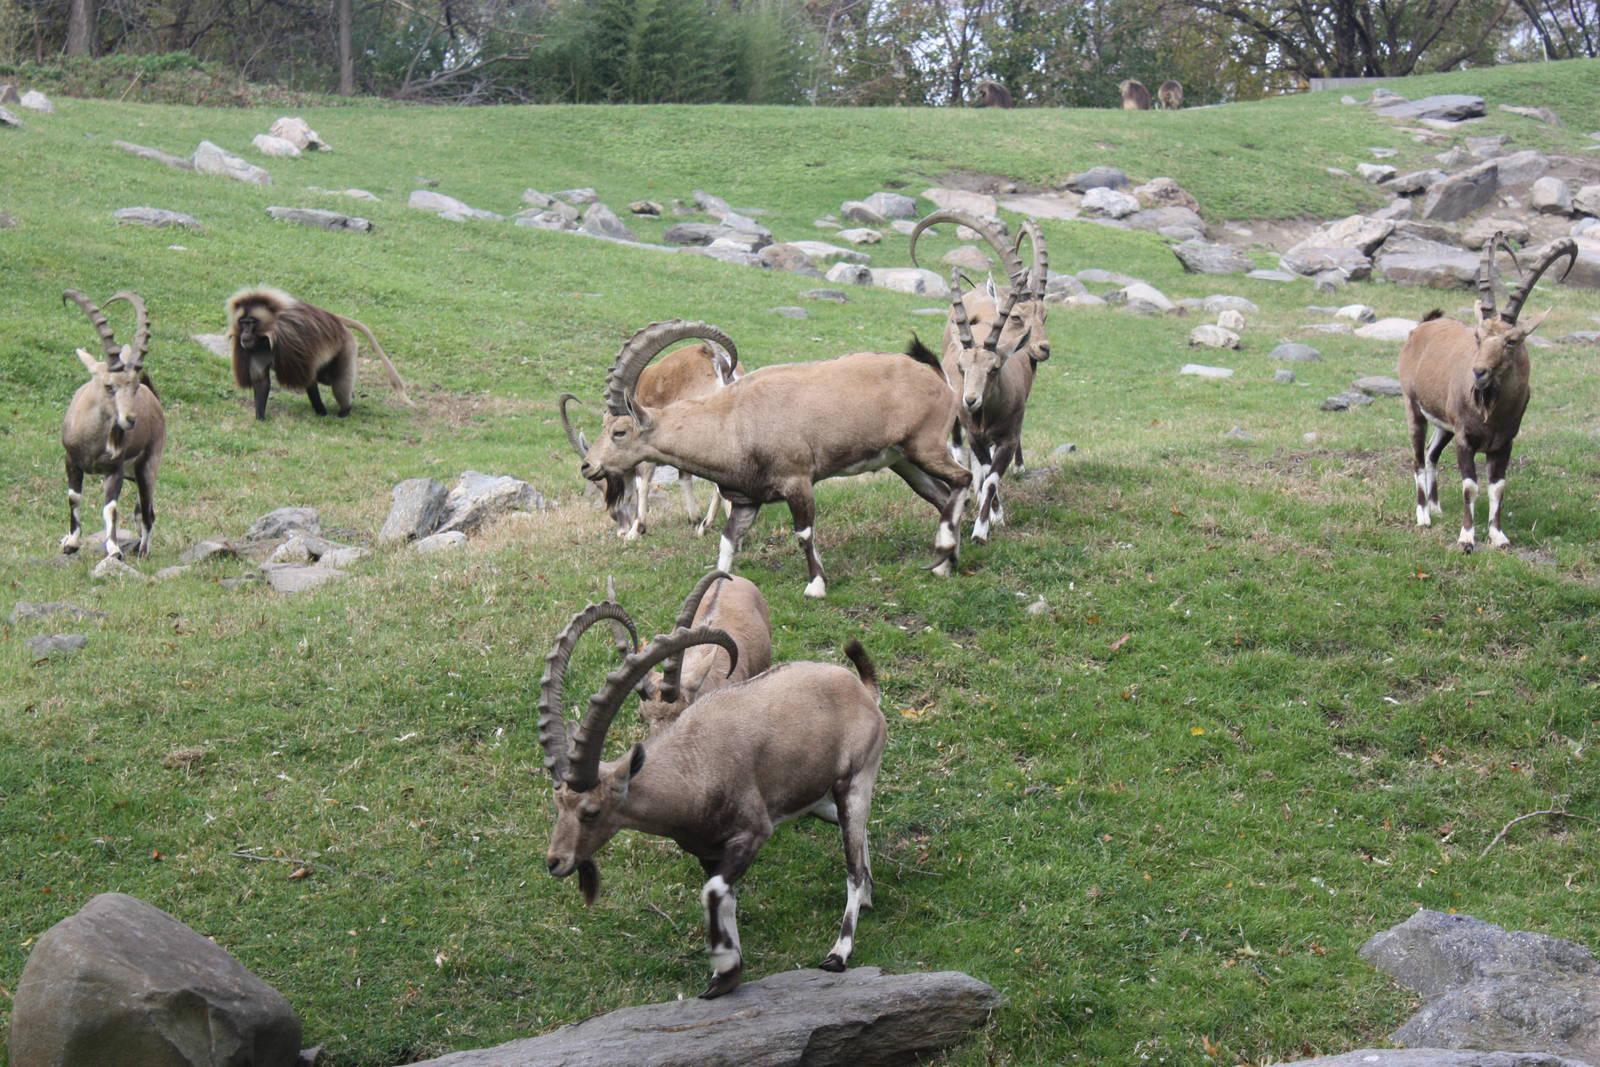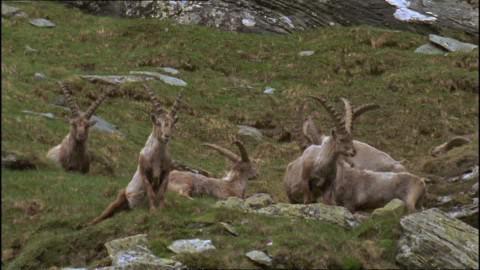The first image is the image on the left, the second image is the image on the right. Analyze the images presented: Is the assertion "A majority of horned animals in one image are rear-facing, and the other image shows a rocky ledge that drops off." valid? Answer yes or no. No. 